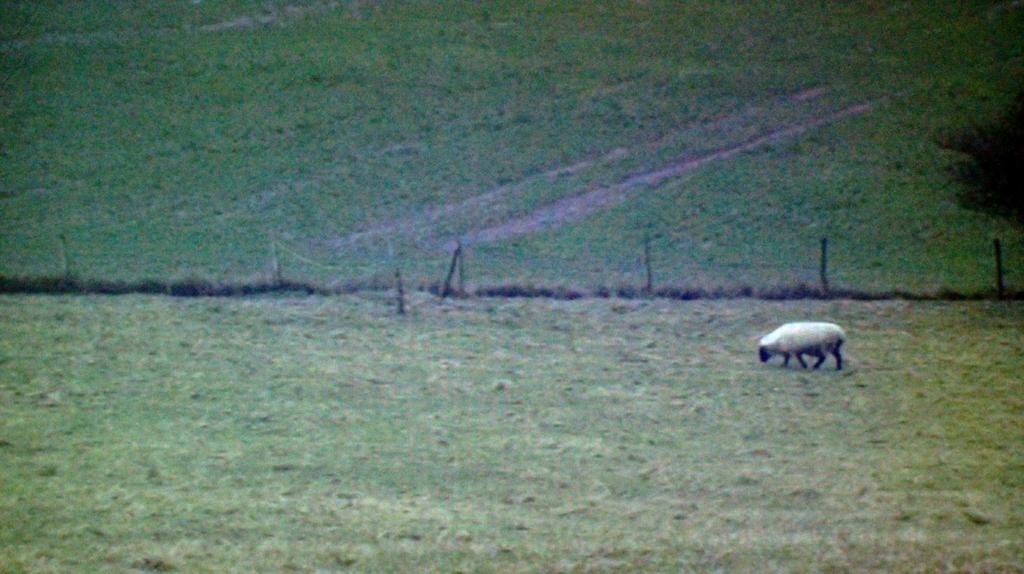What is the main feature of the image? There is a big land in the image. What type of vegetation covers the land? The land is filled with grass. What animal can be seen in the image? A sheep is grazing the grass. What type of tooth can be seen in the image? There are no teeth present in the image; it features a big land with grass and a grazing sheep. Can you tell me who is cooking in the image? There is no one cooking in the image; it only shows a big land with grass and a grazing sheep. 